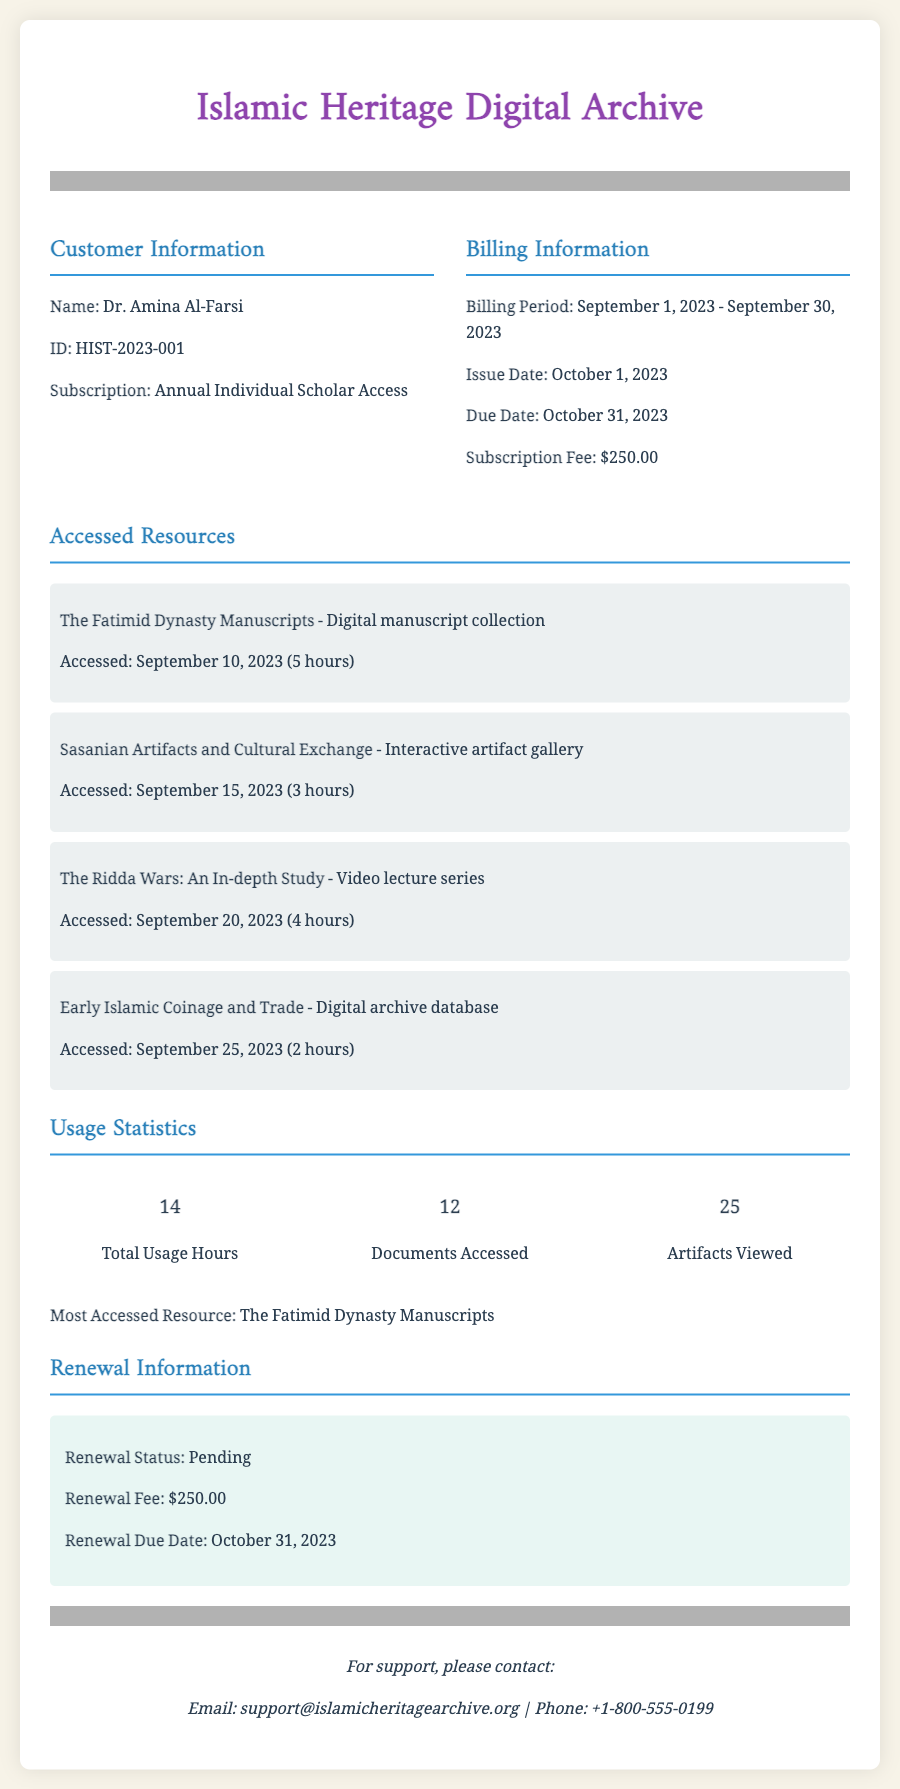What is the name of the customer? The name of the customer is located in the Customer Information section of the document.
Answer: Dr. Amina Al-Farsi What is the subscription type? The subscription type is specified in the Customer Information section of the document.
Answer: Annual Individual Scholar Access What is the billing period? The billing period can be found in the Billing Information section of the document.
Answer: September 1, 2023 - September 30, 2023 How much is the subscription fee? The subscription fee is listed in the Billing Information section of the document.
Answer: $250.00 What is the most accessed resource? The most accessed resource is mentioned in the Usage Statistics section of the document.
Answer: The Fatimid Dynasty Manuscripts How many total usage hours are recorded? The total usage hours are available in the Usage Statistics section of the document.
Answer: 14 What is the renewal status? The renewal status is specified in the Renewal Information section of the document.
Answer: Pending When is the renewal due date? The renewal due date is found in the Renewal Information section of the document.
Answer: October 31, 2023 How many documents were accessed? The number of documents accessed is provided in the Usage Statistics section of the document.
Answer: 12 